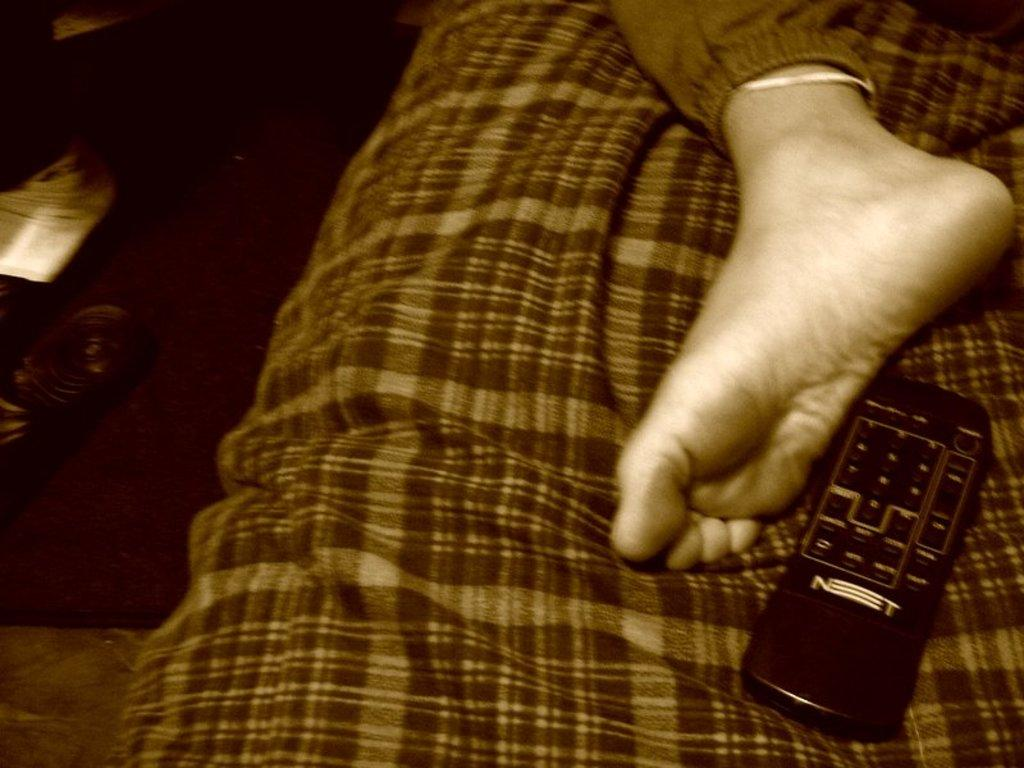<image>
Describe the image concisely. A black hand held remote with the letter N at the bottom. 